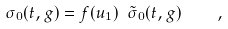Convert formula to latex. <formula><loc_0><loc_0><loc_500><loc_500>\sigma _ { 0 } ( t , g ) = f ( u _ { 1 } ) \ \tilde { \sigma } _ { 0 } ( t , g ) \quad ,</formula> 